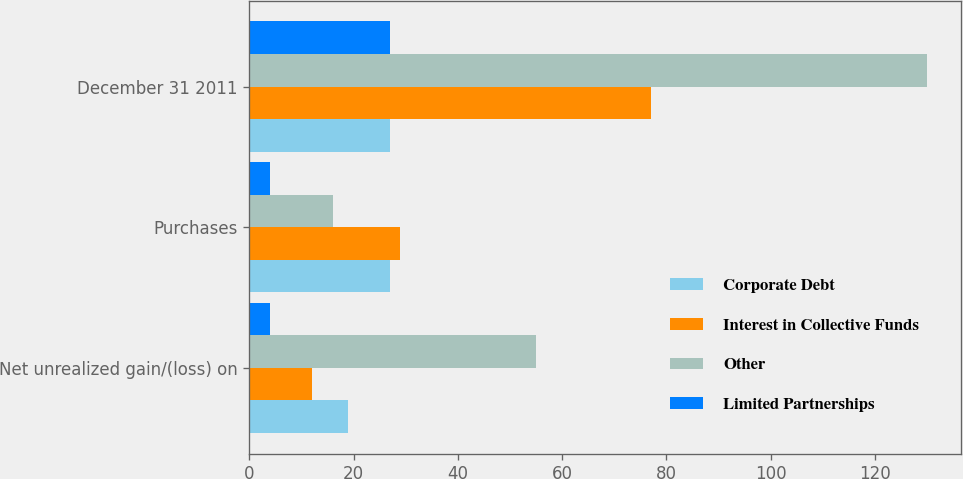<chart> <loc_0><loc_0><loc_500><loc_500><stacked_bar_chart><ecel><fcel>Net unrealized gain/(loss) on<fcel>Purchases<fcel>December 31 2011<nl><fcel>Corporate Debt<fcel>19<fcel>27<fcel>27<nl><fcel>Interest in Collective Funds<fcel>12<fcel>29<fcel>77<nl><fcel>Other<fcel>55<fcel>16<fcel>130<nl><fcel>Limited Partnerships<fcel>4<fcel>4<fcel>27<nl></chart> 